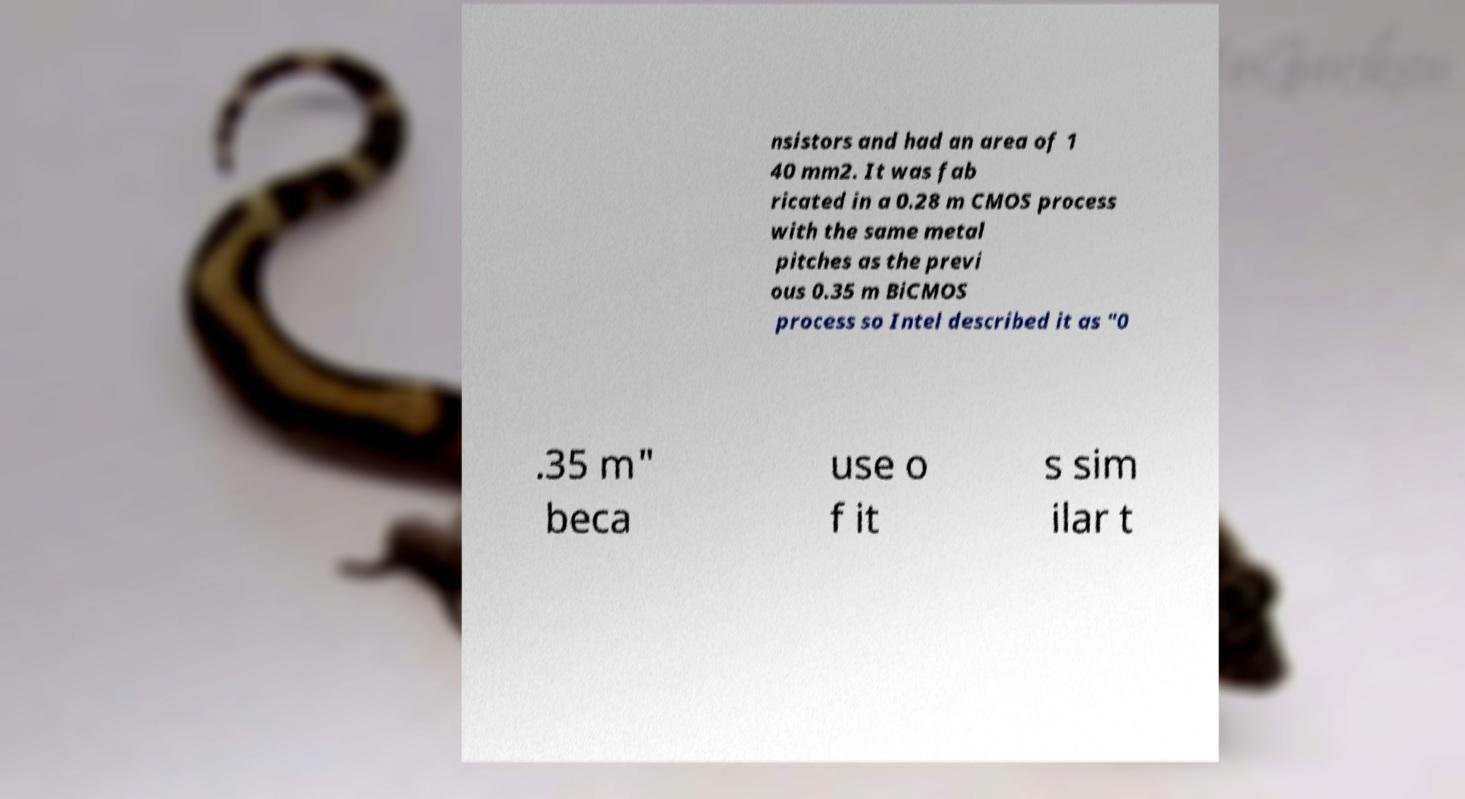What messages or text are displayed in this image? I need them in a readable, typed format. nsistors and had an area of 1 40 mm2. It was fab ricated in a 0.28 m CMOS process with the same metal pitches as the previ ous 0.35 m BiCMOS process so Intel described it as "0 .35 m" beca use o f it s sim ilar t 